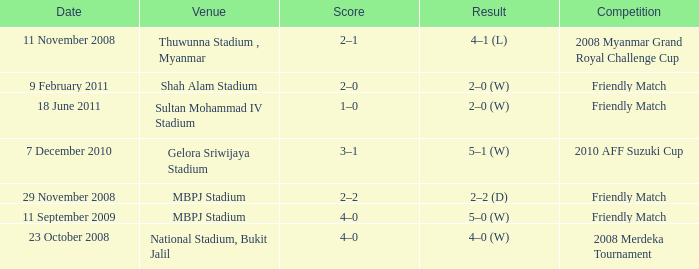What is the Result of the Competition at MBPJ Stadium with a Score of 4–0? 5–0 (W). 